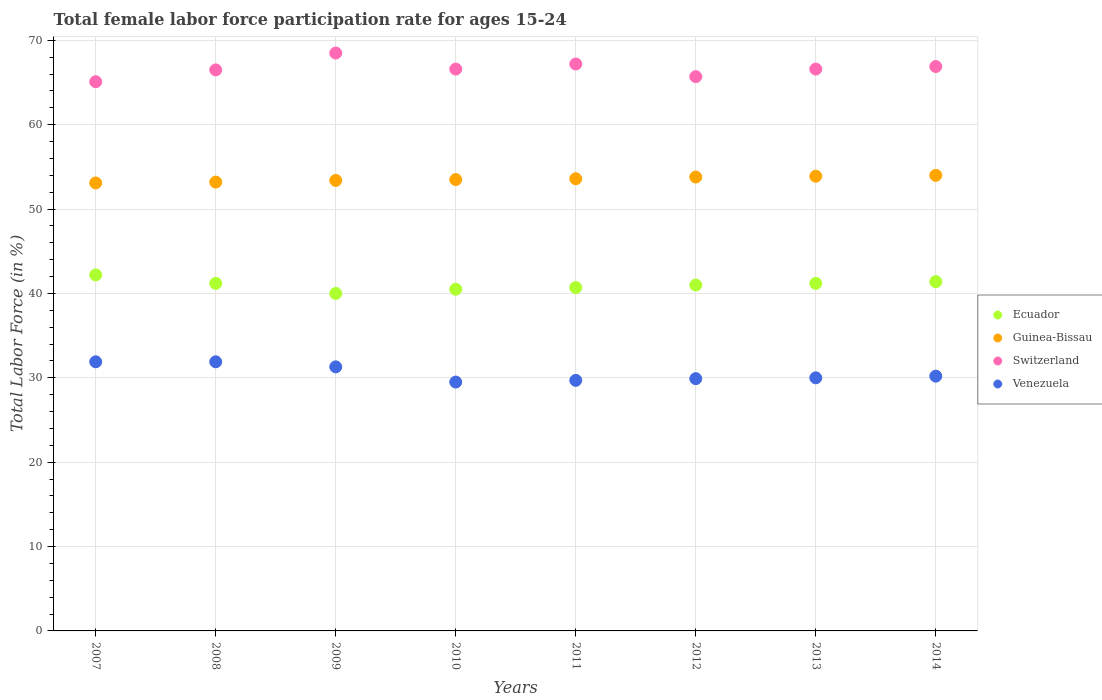Is the number of dotlines equal to the number of legend labels?
Your answer should be very brief. Yes. Across all years, what is the maximum female labor force participation rate in Guinea-Bissau?
Provide a succinct answer. 54. Across all years, what is the minimum female labor force participation rate in Ecuador?
Make the answer very short. 40. In which year was the female labor force participation rate in Ecuador maximum?
Make the answer very short. 2007. What is the total female labor force participation rate in Switzerland in the graph?
Keep it short and to the point. 533.1. What is the difference between the female labor force participation rate in Switzerland in 2010 and that in 2013?
Provide a succinct answer. 0. What is the difference between the female labor force participation rate in Switzerland in 2011 and the female labor force participation rate in Venezuela in 2012?
Give a very brief answer. 37.3. What is the average female labor force participation rate in Venezuela per year?
Offer a very short reply. 30.55. What is the ratio of the female labor force participation rate in Switzerland in 2008 to that in 2013?
Make the answer very short. 1. Is the female labor force participation rate in Venezuela in 2009 less than that in 2014?
Offer a very short reply. No. What is the difference between the highest and the lowest female labor force participation rate in Guinea-Bissau?
Ensure brevity in your answer.  0.9. In how many years, is the female labor force participation rate in Guinea-Bissau greater than the average female labor force participation rate in Guinea-Bissau taken over all years?
Your response must be concise. 4. Is the sum of the female labor force participation rate in Venezuela in 2012 and 2014 greater than the maximum female labor force participation rate in Ecuador across all years?
Provide a short and direct response. Yes. Is it the case that in every year, the sum of the female labor force participation rate in Switzerland and female labor force participation rate in Ecuador  is greater than the female labor force participation rate in Venezuela?
Offer a very short reply. Yes. Is the female labor force participation rate in Ecuador strictly greater than the female labor force participation rate in Venezuela over the years?
Provide a short and direct response. Yes. Is the female labor force participation rate in Switzerland strictly less than the female labor force participation rate in Guinea-Bissau over the years?
Your response must be concise. No. How many years are there in the graph?
Your answer should be compact. 8. Are the values on the major ticks of Y-axis written in scientific E-notation?
Offer a very short reply. No. Where does the legend appear in the graph?
Offer a terse response. Center right. How many legend labels are there?
Offer a very short reply. 4. What is the title of the graph?
Your answer should be compact. Total female labor force participation rate for ages 15-24. What is the label or title of the X-axis?
Offer a very short reply. Years. What is the Total Labor Force (in %) of Ecuador in 2007?
Provide a short and direct response. 42.2. What is the Total Labor Force (in %) in Guinea-Bissau in 2007?
Your answer should be very brief. 53.1. What is the Total Labor Force (in %) of Switzerland in 2007?
Offer a very short reply. 65.1. What is the Total Labor Force (in %) of Venezuela in 2007?
Make the answer very short. 31.9. What is the Total Labor Force (in %) in Ecuador in 2008?
Your response must be concise. 41.2. What is the Total Labor Force (in %) of Guinea-Bissau in 2008?
Make the answer very short. 53.2. What is the Total Labor Force (in %) in Switzerland in 2008?
Ensure brevity in your answer.  66.5. What is the Total Labor Force (in %) of Venezuela in 2008?
Make the answer very short. 31.9. What is the Total Labor Force (in %) in Guinea-Bissau in 2009?
Your response must be concise. 53.4. What is the Total Labor Force (in %) of Switzerland in 2009?
Provide a succinct answer. 68.5. What is the Total Labor Force (in %) of Venezuela in 2009?
Your answer should be compact. 31.3. What is the Total Labor Force (in %) in Ecuador in 2010?
Make the answer very short. 40.5. What is the Total Labor Force (in %) in Guinea-Bissau in 2010?
Provide a short and direct response. 53.5. What is the Total Labor Force (in %) of Switzerland in 2010?
Your answer should be very brief. 66.6. What is the Total Labor Force (in %) in Venezuela in 2010?
Provide a succinct answer. 29.5. What is the Total Labor Force (in %) of Ecuador in 2011?
Give a very brief answer. 40.7. What is the Total Labor Force (in %) of Guinea-Bissau in 2011?
Your answer should be very brief. 53.6. What is the Total Labor Force (in %) of Switzerland in 2011?
Your response must be concise. 67.2. What is the Total Labor Force (in %) in Venezuela in 2011?
Your response must be concise. 29.7. What is the Total Labor Force (in %) of Ecuador in 2012?
Your answer should be very brief. 41. What is the Total Labor Force (in %) of Guinea-Bissau in 2012?
Offer a very short reply. 53.8. What is the Total Labor Force (in %) of Switzerland in 2012?
Offer a terse response. 65.7. What is the Total Labor Force (in %) in Venezuela in 2012?
Ensure brevity in your answer.  29.9. What is the Total Labor Force (in %) of Ecuador in 2013?
Your response must be concise. 41.2. What is the Total Labor Force (in %) in Guinea-Bissau in 2013?
Give a very brief answer. 53.9. What is the Total Labor Force (in %) in Switzerland in 2013?
Your response must be concise. 66.6. What is the Total Labor Force (in %) in Venezuela in 2013?
Offer a terse response. 30. What is the Total Labor Force (in %) of Ecuador in 2014?
Provide a short and direct response. 41.4. What is the Total Labor Force (in %) of Switzerland in 2014?
Provide a short and direct response. 66.9. What is the Total Labor Force (in %) in Venezuela in 2014?
Provide a succinct answer. 30.2. Across all years, what is the maximum Total Labor Force (in %) of Ecuador?
Ensure brevity in your answer.  42.2. Across all years, what is the maximum Total Labor Force (in %) of Switzerland?
Ensure brevity in your answer.  68.5. Across all years, what is the maximum Total Labor Force (in %) in Venezuela?
Give a very brief answer. 31.9. Across all years, what is the minimum Total Labor Force (in %) in Ecuador?
Your answer should be very brief. 40. Across all years, what is the minimum Total Labor Force (in %) in Guinea-Bissau?
Your answer should be compact. 53.1. Across all years, what is the minimum Total Labor Force (in %) of Switzerland?
Offer a very short reply. 65.1. Across all years, what is the minimum Total Labor Force (in %) in Venezuela?
Your response must be concise. 29.5. What is the total Total Labor Force (in %) in Ecuador in the graph?
Give a very brief answer. 328.2. What is the total Total Labor Force (in %) in Guinea-Bissau in the graph?
Provide a short and direct response. 428.5. What is the total Total Labor Force (in %) of Switzerland in the graph?
Provide a short and direct response. 533.1. What is the total Total Labor Force (in %) of Venezuela in the graph?
Provide a succinct answer. 244.4. What is the difference between the Total Labor Force (in %) in Venezuela in 2007 and that in 2008?
Give a very brief answer. 0. What is the difference between the Total Labor Force (in %) in Ecuador in 2007 and that in 2009?
Provide a succinct answer. 2.2. What is the difference between the Total Labor Force (in %) of Switzerland in 2007 and that in 2009?
Keep it short and to the point. -3.4. What is the difference between the Total Labor Force (in %) of Venezuela in 2007 and that in 2009?
Make the answer very short. 0.6. What is the difference between the Total Labor Force (in %) of Ecuador in 2007 and that in 2010?
Ensure brevity in your answer.  1.7. What is the difference between the Total Labor Force (in %) of Guinea-Bissau in 2007 and that in 2010?
Provide a short and direct response. -0.4. What is the difference between the Total Labor Force (in %) in Switzerland in 2007 and that in 2011?
Provide a short and direct response. -2.1. What is the difference between the Total Labor Force (in %) of Venezuela in 2007 and that in 2011?
Your answer should be very brief. 2.2. What is the difference between the Total Labor Force (in %) in Guinea-Bissau in 2007 and that in 2012?
Make the answer very short. -0.7. What is the difference between the Total Labor Force (in %) in Ecuador in 2007 and that in 2013?
Your answer should be very brief. 1. What is the difference between the Total Labor Force (in %) of Guinea-Bissau in 2007 and that in 2013?
Your answer should be compact. -0.8. What is the difference between the Total Labor Force (in %) in Switzerland in 2007 and that in 2013?
Ensure brevity in your answer.  -1.5. What is the difference between the Total Labor Force (in %) in Venezuela in 2007 and that in 2013?
Give a very brief answer. 1.9. What is the difference between the Total Labor Force (in %) of Ecuador in 2007 and that in 2014?
Your response must be concise. 0.8. What is the difference between the Total Labor Force (in %) in Switzerland in 2007 and that in 2014?
Provide a short and direct response. -1.8. What is the difference between the Total Labor Force (in %) of Venezuela in 2007 and that in 2014?
Ensure brevity in your answer.  1.7. What is the difference between the Total Labor Force (in %) in Ecuador in 2008 and that in 2010?
Offer a terse response. 0.7. What is the difference between the Total Labor Force (in %) in Guinea-Bissau in 2008 and that in 2010?
Offer a terse response. -0.3. What is the difference between the Total Labor Force (in %) in Ecuador in 2008 and that in 2011?
Your answer should be very brief. 0.5. What is the difference between the Total Labor Force (in %) of Guinea-Bissau in 2008 and that in 2011?
Provide a short and direct response. -0.4. What is the difference between the Total Labor Force (in %) in Ecuador in 2008 and that in 2012?
Give a very brief answer. 0.2. What is the difference between the Total Labor Force (in %) of Switzerland in 2008 and that in 2012?
Provide a short and direct response. 0.8. What is the difference between the Total Labor Force (in %) of Guinea-Bissau in 2008 and that in 2013?
Offer a very short reply. -0.7. What is the difference between the Total Labor Force (in %) in Switzerland in 2008 and that in 2014?
Make the answer very short. -0.4. What is the difference between the Total Labor Force (in %) in Guinea-Bissau in 2009 and that in 2010?
Offer a terse response. -0.1. What is the difference between the Total Labor Force (in %) in Ecuador in 2009 and that in 2011?
Ensure brevity in your answer.  -0.7. What is the difference between the Total Labor Force (in %) in Guinea-Bissau in 2009 and that in 2011?
Give a very brief answer. -0.2. What is the difference between the Total Labor Force (in %) in Venezuela in 2009 and that in 2011?
Your response must be concise. 1.6. What is the difference between the Total Labor Force (in %) of Ecuador in 2009 and that in 2012?
Make the answer very short. -1. What is the difference between the Total Labor Force (in %) of Switzerland in 2009 and that in 2012?
Your answer should be compact. 2.8. What is the difference between the Total Labor Force (in %) of Venezuela in 2009 and that in 2012?
Your response must be concise. 1.4. What is the difference between the Total Labor Force (in %) in Switzerland in 2009 and that in 2013?
Give a very brief answer. 1.9. What is the difference between the Total Labor Force (in %) in Venezuela in 2009 and that in 2013?
Ensure brevity in your answer.  1.3. What is the difference between the Total Labor Force (in %) in Switzerland in 2009 and that in 2014?
Your answer should be very brief. 1.6. What is the difference between the Total Labor Force (in %) of Venezuela in 2009 and that in 2014?
Make the answer very short. 1.1. What is the difference between the Total Labor Force (in %) of Ecuador in 2010 and that in 2011?
Offer a very short reply. -0.2. What is the difference between the Total Labor Force (in %) in Guinea-Bissau in 2010 and that in 2011?
Ensure brevity in your answer.  -0.1. What is the difference between the Total Labor Force (in %) of Switzerland in 2010 and that in 2011?
Give a very brief answer. -0.6. What is the difference between the Total Labor Force (in %) in Switzerland in 2010 and that in 2012?
Your response must be concise. 0.9. What is the difference between the Total Labor Force (in %) of Ecuador in 2010 and that in 2013?
Give a very brief answer. -0.7. What is the difference between the Total Labor Force (in %) in Switzerland in 2010 and that in 2013?
Give a very brief answer. 0. What is the difference between the Total Labor Force (in %) in Guinea-Bissau in 2010 and that in 2014?
Keep it short and to the point. -0.5. What is the difference between the Total Labor Force (in %) of Ecuador in 2011 and that in 2012?
Your response must be concise. -0.3. What is the difference between the Total Labor Force (in %) of Guinea-Bissau in 2011 and that in 2012?
Ensure brevity in your answer.  -0.2. What is the difference between the Total Labor Force (in %) of Ecuador in 2011 and that in 2013?
Your answer should be very brief. -0.5. What is the difference between the Total Labor Force (in %) of Switzerland in 2011 and that in 2013?
Your answer should be compact. 0.6. What is the difference between the Total Labor Force (in %) of Venezuela in 2011 and that in 2013?
Provide a short and direct response. -0.3. What is the difference between the Total Labor Force (in %) of Ecuador in 2011 and that in 2014?
Ensure brevity in your answer.  -0.7. What is the difference between the Total Labor Force (in %) of Venezuela in 2011 and that in 2014?
Your response must be concise. -0.5. What is the difference between the Total Labor Force (in %) in Switzerland in 2012 and that in 2013?
Provide a succinct answer. -0.9. What is the difference between the Total Labor Force (in %) of Venezuela in 2012 and that in 2013?
Keep it short and to the point. -0.1. What is the difference between the Total Labor Force (in %) of Guinea-Bissau in 2012 and that in 2014?
Your answer should be compact. -0.2. What is the difference between the Total Labor Force (in %) in Ecuador in 2013 and that in 2014?
Ensure brevity in your answer.  -0.2. What is the difference between the Total Labor Force (in %) of Venezuela in 2013 and that in 2014?
Give a very brief answer. -0.2. What is the difference between the Total Labor Force (in %) in Ecuador in 2007 and the Total Labor Force (in %) in Switzerland in 2008?
Make the answer very short. -24.3. What is the difference between the Total Labor Force (in %) in Guinea-Bissau in 2007 and the Total Labor Force (in %) in Venezuela in 2008?
Your answer should be compact. 21.2. What is the difference between the Total Labor Force (in %) in Switzerland in 2007 and the Total Labor Force (in %) in Venezuela in 2008?
Your response must be concise. 33.2. What is the difference between the Total Labor Force (in %) of Ecuador in 2007 and the Total Labor Force (in %) of Guinea-Bissau in 2009?
Offer a very short reply. -11.2. What is the difference between the Total Labor Force (in %) in Ecuador in 2007 and the Total Labor Force (in %) in Switzerland in 2009?
Give a very brief answer. -26.3. What is the difference between the Total Labor Force (in %) of Ecuador in 2007 and the Total Labor Force (in %) of Venezuela in 2009?
Keep it short and to the point. 10.9. What is the difference between the Total Labor Force (in %) of Guinea-Bissau in 2007 and the Total Labor Force (in %) of Switzerland in 2009?
Your answer should be very brief. -15.4. What is the difference between the Total Labor Force (in %) in Guinea-Bissau in 2007 and the Total Labor Force (in %) in Venezuela in 2009?
Your response must be concise. 21.8. What is the difference between the Total Labor Force (in %) in Switzerland in 2007 and the Total Labor Force (in %) in Venezuela in 2009?
Make the answer very short. 33.8. What is the difference between the Total Labor Force (in %) in Ecuador in 2007 and the Total Labor Force (in %) in Switzerland in 2010?
Offer a very short reply. -24.4. What is the difference between the Total Labor Force (in %) of Guinea-Bissau in 2007 and the Total Labor Force (in %) of Venezuela in 2010?
Your answer should be compact. 23.6. What is the difference between the Total Labor Force (in %) of Switzerland in 2007 and the Total Labor Force (in %) of Venezuela in 2010?
Provide a succinct answer. 35.6. What is the difference between the Total Labor Force (in %) in Ecuador in 2007 and the Total Labor Force (in %) in Switzerland in 2011?
Ensure brevity in your answer.  -25. What is the difference between the Total Labor Force (in %) in Guinea-Bissau in 2007 and the Total Labor Force (in %) in Switzerland in 2011?
Your answer should be very brief. -14.1. What is the difference between the Total Labor Force (in %) of Guinea-Bissau in 2007 and the Total Labor Force (in %) of Venezuela in 2011?
Your response must be concise. 23.4. What is the difference between the Total Labor Force (in %) of Switzerland in 2007 and the Total Labor Force (in %) of Venezuela in 2011?
Your answer should be compact. 35.4. What is the difference between the Total Labor Force (in %) of Ecuador in 2007 and the Total Labor Force (in %) of Guinea-Bissau in 2012?
Ensure brevity in your answer.  -11.6. What is the difference between the Total Labor Force (in %) of Ecuador in 2007 and the Total Labor Force (in %) of Switzerland in 2012?
Provide a short and direct response. -23.5. What is the difference between the Total Labor Force (in %) of Ecuador in 2007 and the Total Labor Force (in %) of Venezuela in 2012?
Provide a short and direct response. 12.3. What is the difference between the Total Labor Force (in %) in Guinea-Bissau in 2007 and the Total Labor Force (in %) in Venezuela in 2012?
Make the answer very short. 23.2. What is the difference between the Total Labor Force (in %) of Switzerland in 2007 and the Total Labor Force (in %) of Venezuela in 2012?
Provide a succinct answer. 35.2. What is the difference between the Total Labor Force (in %) in Ecuador in 2007 and the Total Labor Force (in %) in Guinea-Bissau in 2013?
Provide a succinct answer. -11.7. What is the difference between the Total Labor Force (in %) of Ecuador in 2007 and the Total Labor Force (in %) of Switzerland in 2013?
Provide a succinct answer. -24.4. What is the difference between the Total Labor Force (in %) in Guinea-Bissau in 2007 and the Total Labor Force (in %) in Venezuela in 2013?
Your answer should be very brief. 23.1. What is the difference between the Total Labor Force (in %) of Switzerland in 2007 and the Total Labor Force (in %) of Venezuela in 2013?
Ensure brevity in your answer.  35.1. What is the difference between the Total Labor Force (in %) in Ecuador in 2007 and the Total Labor Force (in %) in Guinea-Bissau in 2014?
Offer a terse response. -11.8. What is the difference between the Total Labor Force (in %) of Ecuador in 2007 and the Total Labor Force (in %) of Switzerland in 2014?
Offer a terse response. -24.7. What is the difference between the Total Labor Force (in %) in Guinea-Bissau in 2007 and the Total Labor Force (in %) in Switzerland in 2014?
Ensure brevity in your answer.  -13.8. What is the difference between the Total Labor Force (in %) in Guinea-Bissau in 2007 and the Total Labor Force (in %) in Venezuela in 2014?
Make the answer very short. 22.9. What is the difference between the Total Labor Force (in %) in Switzerland in 2007 and the Total Labor Force (in %) in Venezuela in 2014?
Make the answer very short. 34.9. What is the difference between the Total Labor Force (in %) in Ecuador in 2008 and the Total Labor Force (in %) in Switzerland in 2009?
Give a very brief answer. -27.3. What is the difference between the Total Labor Force (in %) in Guinea-Bissau in 2008 and the Total Labor Force (in %) in Switzerland in 2009?
Offer a terse response. -15.3. What is the difference between the Total Labor Force (in %) in Guinea-Bissau in 2008 and the Total Labor Force (in %) in Venezuela in 2009?
Keep it short and to the point. 21.9. What is the difference between the Total Labor Force (in %) in Switzerland in 2008 and the Total Labor Force (in %) in Venezuela in 2009?
Keep it short and to the point. 35.2. What is the difference between the Total Labor Force (in %) of Ecuador in 2008 and the Total Labor Force (in %) of Guinea-Bissau in 2010?
Keep it short and to the point. -12.3. What is the difference between the Total Labor Force (in %) in Ecuador in 2008 and the Total Labor Force (in %) in Switzerland in 2010?
Provide a succinct answer. -25.4. What is the difference between the Total Labor Force (in %) of Ecuador in 2008 and the Total Labor Force (in %) of Venezuela in 2010?
Your answer should be compact. 11.7. What is the difference between the Total Labor Force (in %) in Guinea-Bissau in 2008 and the Total Labor Force (in %) in Venezuela in 2010?
Make the answer very short. 23.7. What is the difference between the Total Labor Force (in %) of Ecuador in 2008 and the Total Labor Force (in %) of Venezuela in 2011?
Make the answer very short. 11.5. What is the difference between the Total Labor Force (in %) of Guinea-Bissau in 2008 and the Total Labor Force (in %) of Switzerland in 2011?
Give a very brief answer. -14. What is the difference between the Total Labor Force (in %) in Switzerland in 2008 and the Total Labor Force (in %) in Venezuela in 2011?
Your response must be concise. 36.8. What is the difference between the Total Labor Force (in %) of Ecuador in 2008 and the Total Labor Force (in %) of Guinea-Bissau in 2012?
Offer a terse response. -12.6. What is the difference between the Total Labor Force (in %) in Ecuador in 2008 and the Total Labor Force (in %) in Switzerland in 2012?
Your answer should be compact. -24.5. What is the difference between the Total Labor Force (in %) in Guinea-Bissau in 2008 and the Total Labor Force (in %) in Venezuela in 2012?
Ensure brevity in your answer.  23.3. What is the difference between the Total Labor Force (in %) in Switzerland in 2008 and the Total Labor Force (in %) in Venezuela in 2012?
Your answer should be very brief. 36.6. What is the difference between the Total Labor Force (in %) of Ecuador in 2008 and the Total Labor Force (in %) of Switzerland in 2013?
Your answer should be compact. -25.4. What is the difference between the Total Labor Force (in %) of Guinea-Bissau in 2008 and the Total Labor Force (in %) of Switzerland in 2013?
Give a very brief answer. -13.4. What is the difference between the Total Labor Force (in %) in Guinea-Bissau in 2008 and the Total Labor Force (in %) in Venezuela in 2013?
Provide a short and direct response. 23.2. What is the difference between the Total Labor Force (in %) of Switzerland in 2008 and the Total Labor Force (in %) of Venezuela in 2013?
Give a very brief answer. 36.5. What is the difference between the Total Labor Force (in %) of Ecuador in 2008 and the Total Labor Force (in %) of Guinea-Bissau in 2014?
Make the answer very short. -12.8. What is the difference between the Total Labor Force (in %) in Ecuador in 2008 and the Total Labor Force (in %) in Switzerland in 2014?
Ensure brevity in your answer.  -25.7. What is the difference between the Total Labor Force (in %) in Ecuador in 2008 and the Total Labor Force (in %) in Venezuela in 2014?
Your answer should be very brief. 11. What is the difference between the Total Labor Force (in %) in Guinea-Bissau in 2008 and the Total Labor Force (in %) in Switzerland in 2014?
Offer a very short reply. -13.7. What is the difference between the Total Labor Force (in %) in Switzerland in 2008 and the Total Labor Force (in %) in Venezuela in 2014?
Offer a terse response. 36.3. What is the difference between the Total Labor Force (in %) in Ecuador in 2009 and the Total Labor Force (in %) in Switzerland in 2010?
Make the answer very short. -26.6. What is the difference between the Total Labor Force (in %) in Guinea-Bissau in 2009 and the Total Labor Force (in %) in Venezuela in 2010?
Your answer should be very brief. 23.9. What is the difference between the Total Labor Force (in %) of Ecuador in 2009 and the Total Labor Force (in %) of Switzerland in 2011?
Your response must be concise. -27.2. What is the difference between the Total Labor Force (in %) of Ecuador in 2009 and the Total Labor Force (in %) of Venezuela in 2011?
Provide a short and direct response. 10.3. What is the difference between the Total Labor Force (in %) of Guinea-Bissau in 2009 and the Total Labor Force (in %) of Switzerland in 2011?
Your answer should be compact. -13.8. What is the difference between the Total Labor Force (in %) in Guinea-Bissau in 2009 and the Total Labor Force (in %) in Venezuela in 2011?
Give a very brief answer. 23.7. What is the difference between the Total Labor Force (in %) of Switzerland in 2009 and the Total Labor Force (in %) of Venezuela in 2011?
Provide a short and direct response. 38.8. What is the difference between the Total Labor Force (in %) of Ecuador in 2009 and the Total Labor Force (in %) of Guinea-Bissau in 2012?
Give a very brief answer. -13.8. What is the difference between the Total Labor Force (in %) in Ecuador in 2009 and the Total Labor Force (in %) in Switzerland in 2012?
Keep it short and to the point. -25.7. What is the difference between the Total Labor Force (in %) in Ecuador in 2009 and the Total Labor Force (in %) in Venezuela in 2012?
Make the answer very short. 10.1. What is the difference between the Total Labor Force (in %) in Switzerland in 2009 and the Total Labor Force (in %) in Venezuela in 2012?
Offer a terse response. 38.6. What is the difference between the Total Labor Force (in %) of Ecuador in 2009 and the Total Labor Force (in %) of Switzerland in 2013?
Give a very brief answer. -26.6. What is the difference between the Total Labor Force (in %) in Ecuador in 2009 and the Total Labor Force (in %) in Venezuela in 2013?
Ensure brevity in your answer.  10. What is the difference between the Total Labor Force (in %) in Guinea-Bissau in 2009 and the Total Labor Force (in %) in Switzerland in 2013?
Offer a very short reply. -13.2. What is the difference between the Total Labor Force (in %) of Guinea-Bissau in 2009 and the Total Labor Force (in %) of Venezuela in 2013?
Provide a short and direct response. 23.4. What is the difference between the Total Labor Force (in %) of Switzerland in 2009 and the Total Labor Force (in %) of Venezuela in 2013?
Ensure brevity in your answer.  38.5. What is the difference between the Total Labor Force (in %) of Ecuador in 2009 and the Total Labor Force (in %) of Guinea-Bissau in 2014?
Ensure brevity in your answer.  -14. What is the difference between the Total Labor Force (in %) of Ecuador in 2009 and the Total Labor Force (in %) of Switzerland in 2014?
Make the answer very short. -26.9. What is the difference between the Total Labor Force (in %) of Ecuador in 2009 and the Total Labor Force (in %) of Venezuela in 2014?
Ensure brevity in your answer.  9.8. What is the difference between the Total Labor Force (in %) in Guinea-Bissau in 2009 and the Total Labor Force (in %) in Venezuela in 2014?
Your answer should be very brief. 23.2. What is the difference between the Total Labor Force (in %) in Switzerland in 2009 and the Total Labor Force (in %) in Venezuela in 2014?
Offer a very short reply. 38.3. What is the difference between the Total Labor Force (in %) of Ecuador in 2010 and the Total Labor Force (in %) of Switzerland in 2011?
Your answer should be very brief. -26.7. What is the difference between the Total Labor Force (in %) of Ecuador in 2010 and the Total Labor Force (in %) of Venezuela in 2011?
Give a very brief answer. 10.8. What is the difference between the Total Labor Force (in %) in Guinea-Bissau in 2010 and the Total Labor Force (in %) in Switzerland in 2011?
Offer a very short reply. -13.7. What is the difference between the Total Labor Force (in %) of Guinea-Bissau in 2010 and the Total Labor Force (in %) of Venezuela in 2011?
Give a very brief answer. 23.8. What is the difference between the Total Labor Force (in %) of Switzerland in 2010 and the Total Labor Force (in %) of Venezuela in 2011?
Keep it short and to the point. 36.9. What is the difference between the Total Labor Force (in %) of Ecuador in 2010 and the Total Labor Force (in %) of Switzerland in 2012?
Give a very brief answer. -25.2. What is the difference between the Total Labor Force (in %) of Guinea-Bissau in 2010 and the Total Labor Force (in %) of Venezuela in 2012?
Offer a terse response. 23.6. What is the difference between the Total Labor Force (in %) in Switzerland in 2010 and the Total Labor Force (in %) in Venezuela in 2012?
Your response must be concise. 36.7. What is the difference between the Total Labor Force (in %) of Ecuador in 2010 and the Total Labor Force (in %) of Guinea-Bissau in 2013?
Offer a very short reply. -13.4. What is the difference between the Total Labor Force (in %) of Ecuador in 2010 and the Total Labor Force (in %) of Switzerland in 2013?
Keep it short and to the point. -26.1. What is the difference between the Total Labor Force (in %) in Switzerland in 2010 and the Total Labor Force (in %) in Venezuela in 2013?
Keep it short and to the point. 36.6. What is the difference between the Total Labor Force (in %) of Ecuador in 2010 and the Total Labor Force (in %) of Guinea-Bissau in 2014?
Make the answer very short. -13.5. What is the difference between the Total Labor Force (in %) in Ecuador in 2010 and the Total Labor Force (in %) in Switzerland in 2014?
Offer a very short reply. -26.4. What is the difference between the Total Labor Force (in %) in Ecuador in 2010 and the Total Labor Force (in %) in Venezuela in 2014?
Provide a succinct answer. 10.3. What is the difference between the Total Labor Force (in %) in Guinea-Bissau in 2010 and the Total Labor Force (in %) in Switzerland in 2014?
Ensure brevity in your answer.  -13.4. What is the difference between the Total Labor Force (in %) in Guinea-Bissau in 2010 and the Total Labor Force (in %) in Venezuela in 2014?
Provide a succinct answer. 23.3. What is the difference between the Total Labor Force (in %) of Switzerland in 2010 and the Total Labor Force (in %) of Venezuela in 2014?
Your answer should be very brief. 36.4. What is the difference between the Total Labor Force (in %) in Ecuador in 2011 and the Total Labor Force (in %) in Guinea-Bissau in 2012?
Your answer should be very brief. -13.1. What is the difference between the Total Labor Force (in %) in Ecuador in 2011 and the Total Labor Force (in %) in Venezuela in 2012?
Provide a short and direct response. 10.8. What is the difference between the Total Labor Force (in %) of Guinea-Bissau in 2011 and the Total Labor Force (in %) of Switzerland in 2012?
Provide a succinct answer. -12.1. What is the difference between the Total Labor Force (in %) in Guinea-Bissau in 2011 and the Total Labor Force (in %) in Venezuela in 2012?
Offer a terse response. 23.7. What is the difference between the Total Labor Force (in %) of Switzerland in 2011 and the Total Labor Force (in %) of Venezuela in 2012?
Offer a very short reply. 37.3. What is the difference between the Total Labor Force (in %) of Ecuador in 2011 and the Total Labor Force (in %) of Switzerland in 2013?
Keep it short and to the point. -25.9. What is the difference between the Total Labor Force (in %) in Ecuador in 2011 and the Total Labor Force (in %) in Venezuela in 2013?
Provide a succinct answer. 10.7. What is the difference between the Total Labor Force (in %) in Guinea-Bissau in 2011 and the Total Labor Force (in %) in Switzerland in 2013?
Offer a terse response. -13. What is the difference between the Total Labor Force (in %) of Guinea-Bissau in 2011 and the Total Labor Force (in %) of Venezuela in 2013?
Your answer should be compact. 23.6. What is the difference between the Total Labor Force (in %) in Switzerland in 2011 and the Total Labor Force (in %) in Venezuela in 2013?
Offer a very short reply. 37.2. What is the difference between the Total Labor Force (in %) of Ecuador in 2011 and the Total Labor Force (in %) of Switzerland in 2014?
Your answer should be very brief. -26.2. What is the difference between the Total Labor Force (in %) in Guinea-Bissau in 2011 and the Total Labor Force (in %) in Venezuela in 2014?
Provide a short and direct response. 23.4. What is the difference between the Total Labor Force (in %) in Ecuador in 2012 and the Total Labor Force (in %) in Guinea-Bissau in 2013?
Offer a terse response. -12.9. What is the difference between the Total Labor Force (in %) of Ecuador in 2012 and the Total Labor Force (in %) of Switzerland in 2013?
Your answer should be very brief. -25.6. What is the difference between the Total Labor Force (in %) of Ecuador in 2012 and the Total Labor Force (in %) of Venezuela in 2013?
Make the answer very short. 11. What is the difference between the Total Labor Force (in %) in Guinea-Bissau in 2012 and the Total Labor Force (in %) in Switzerland in 2013?
Ensure brevity in your answer.  -12.8. What is the difference between the Total Labor Force (in %) in Guinea-Bissau in 2012 and the Total Labor Force (in %) in Venezuela in 2013?
Your response must be concise. 23.8. What is the difference between the Total Labor Force (in %) in Switzerland in 2012 and the Total Labor Force (in %) in Venezuela in 2013?
Offer a very short reply. 35.7. What is the difference between the Total Labor Force (in %) in Ecuador in 2012 and the Total Labor Force (in %) in Guinea-Bissau in 2014?
Offer a very short reply. -13. What is the difference between the Total Labor Force (in %) in Ecuador in 2012 and the Total Labor Force (in %) in Switzerland in 2014?
Your answer should be compact. -25.9. What is the difference between the Total Labor Force (in %) in Ecuador in 2012 and the Total Labor Force (in %) in Venezuela in 2014?
Your response must be concise. 10.8. What is the difference between the Total Labor Force (in %) of Guinea-Bissau in 2012 and the Total Labor Force (in %) of Switzerland in 2014?
Make the answer very short. -13.1. What is the difference between the Total Labor Force (in %) in Guinea-Bissau in 2012 and the Total Labor Force (in %) in Venezuela in 2014?
Make the answer very short. 23.6. What is the difference between the Total Labor Force (in %) of Switzerland in 2012 and the Total Labor Force (in %) of Venezuela in 2014?
Make the answer very short. 35.5. What is the difference between the Total Labor Force (in %) in Ecuador in 2013 and the Total Labor Force (in %) in Guinea-Bissau in 2014?
Provide a succinct answer. -12.8. What is the difference between the Total Labor Force (in %) of Ecuador in 2013 and the Total Labor Force (in %) of Switzerland in 2014?
Your response must be concise. -25.7. What is the difference between the Total Labor Force (in %) of Guinea-Bissau in 2013 and the Total Labor Force (in %) of Switzerland in 2014?
Offer a terse response. -13. What is the difference between the Total Labor Force (in %) in Guinea-Bissau in 2013 and the Total Labor Force (in %) in Venezuela in 2014?
Make the answer very short. 23.7. What is the difference between the Total Labor Force (in %) in Switzerland in 2013 and the Total Labor Force (in %) in Venezuela in 2014?
Provide a succinct answer. 36.4. What is the average Total Labor Force (in %) in Ecuador per year?
Ensure brevity in your answer.  41.02. What is the average Total Labor Force (in %) in Guinea-Bissau per year?
Provide a short and direct response. 53.56. What is the average Total Labor Force (in %) in Switzerland per year?
Make the answer very short. 66.64. What is the average Total Labor Force (in %) in Venezuela per year?
Your response must be concise. 30.55. In the year 2007, what is the difference between the Total Labor Force (in %) in Ecuador and Total Labor Force (in %) in Switzerland?
Provide a short and direct response. -22.9. In the year 2007, what is the difference between the Total Labor Force (in %) in Ecuador and Total Labor Force (in %) in Venezuela?
Your answer should be very brief. 10.3. In the year 2007, what is the difference between the Total Labor Force (in %) of Guinea-Bissau and Total Labor Force (in %) of Switzerland?
Provide a short and direct response. -12. In the year 2007, what is the difference between the Total Labor Force (in %) in Guinea-Bissau and Total Labor Force (in %) in Venezuela?
Offer a very short reply. 21.2. In the year 2007, what is the difference between the Total Labor Force (in %) in Switzerland and Total Labor Force (in %) in Venezuela?
Give a very brief answer. 33.2. In the year 2008, what is the difference between the Total Labor Force (in %) of Ecuador and Total Labor Force (in %) of Guinea-Bissau?
Your answer should be very brief. -12. In the year 2008, what is the difference between the Total Labor Force (in %) in Ecuador and Total Labor Force (in %) in Switzerland?
Ensure brevity in your answer.  -25.3. In the year 2008, what is the difference between the Total Labor Force (in %) of Guinea-Bissau and Total Labor Force (in %) of Switzerland?
Keep it short and to the point. -13.3. In the year 2008, what is the difference between the Total Labor Force (in %) in Guinea-Bissau and Total Labor Force (in %) in Venezuela?
Give a very brief answer. 21.3. In the year 2008, what is the difference between the Total Labor Force (in %) in Switzerland and Total Labor Force (in %) in Venezuela?
Offer a terse response. 34.6. In the year 2009, what is the difference between the Total Labor Force (in %) in Ecuador and Total Labor Force (in %) in Guinea-Bissau?
Your answer should be very brief. -13.4. In the year 2009, what is the difference between the Total Labor Force (in %) of Ecuador and Total Labor Force (in %) of Switzerland?
Keep it short and to the point. -28.5. In the year 2009, what is the difference between the Total Labor Force (in %) in Ecuador and Total Labor Force (in %) in Venezuela?
Offer a terse response. 8.7. In the year 2009, what is the difference between the Total Labor Force (in %) of Guinea-Bissau and Total Labor Force (in %) of Switzerland?
Keep it short and to the point. -15.1. In the year 2009, what is the difference between the Total Labor Force (in %) of Guinea-Bissau and Total Labor Force (in %) of Venezuela?
Keep it short and to the point. 22.1. In the year 2009, what is the difference between the Total Labor Force (in %) in Switzerland and Total Labor Force (in %) in Venezuela?
Your answer should be very brief. 37.2. In the year 2010, what is the difference between the Total Labor Force (in %) in Ecuador and Total Labor Force (in %) in Switzerland?
Offer a very short reply. -26.1. In the year 2010, what is the difference between the Total Labor Force (in %) in Ecuador and Total Labor Force (in %) in Venezuela?
Ensure brevity in your answer.  11. In the year 2010, what is the difference between the Total Labor Force (in %) in Guinea-Bissau and Total Labor Force (in %) in Venezuela?
Keep it short and to the point. 24. In the year 2010, what is the difference between the Total Labor Force (in %) in Switzerland and Total Labor Force (in %) in Venezuela?
Your answer should be very brief. 37.1. In the year 2011, what is the difference between the Total Labor Force (in %) of Ecuador and Total Labor Force (in %) of Switzerland?
Provide a succinct answer. -26.5. In the year 2011, what is the difference between the Total Labor Force (in %) of Guinea-Bissau and Total Labor Force (in %) of Venezuela?
Give a very brief answer. 23.9. In the year 2011, what is the difference between the Total Labor Force (in %) in Switzerland and Total Labor Force (in %) in Venezuela?
Ensure brevity in your answer.  37.5. In the year 2012, what is the difference between the Total Labor Force (in %) in Ecuador and Total Labor Force (in %) in Switzerland?
Provide a succinct answer. -24.7. In the year 2012, what is the difference between the Total Labor Force (in %) in Ecuador and Total Labor Force (in %) in Venezuela?
Make the answer very short. 11.1. In the year 2012, what is the difference between the Total Labor Force (in %) of Guinea-Bissau and Total Labor Force (in %) of Switzerland?
Your answer should be compact. -11.9. In the year 2012, what is the difference between the Total Labor Force (in %) of Guinea-Bissau and Total Labor Force (in %) of Venezuela?
Your answer should be compact. 23.9. In the year 2012, what is the difference between the Total Labor Force (in %) in Switzerland and Total Labor Force (in %) in Venezuela?
Make the answer very short. 35.8. In the year 2013, what is the difference between the Total Labor Force (in %) in Ecuador and Total Labor Force (in %) in Switzerland?
Offer a very short reply. -25.4. In the year 2013, what is the difference between the Total Labor Force (in %) of Ecuador and Total Labor Force (in %) of Venezuela?
Your response must be concise. 11.2. In the year 2013, what is the difference between the Total Labor Force (in %) of Guinea-Bissau and Total Labor Force (in %) of Venezuela?
Make the answer very short. 23.9. In the year 2013, what is the difference between the Total Labor Force (in %) of Switzerland and Total Labor Force (in %) of Venezuela?
Offer a very short reply. 36.6. In the year 2014, what is the difference between the Total Labor Force (in %) in Ecuador and Total Labor Force (in %) in Guinea-Bissau?
Ensure brevity in your answer.  -12.6. In the year 2014, what is the difference between the Total Labor Force (in %) in Ecuador and Total Labor Force (in %) in Switzerland?
Your answer should be compact. -25.5. In the year 2014, what is the difference between the Total Labor Force (in %) of Guinea-Bissau and Total Labor Force (in %) of Venezuela?
Your answer should be very brief. 23.8. In the year 2014, what is the difference between the Total Labor Force (in %) of Switzerland and Total Labor Force (in %) of Venezuela?
Keep it short and to the point. 36.7. What is the ratio of the Total Labor Force (in %) of Ecuador in 2007 to that in 2008?
Your answer should be very brief. 1.02. What is the ratio of the Total Labor Force (in %) in Guinea-Bissau in 2007 to that in 2008?
Offer a terse response. 1. What is the ratio of the Total Labor Force (in %) of Switzerland in 2007 to that in 2008?
Your answer should be very brief. 0.98. What is the ratio of the Total Labor Force (in %) in Venezuela in 2007 to that in 2008?
Provide a short and direct response. 1. What is the ratio of the Total Labor Force (in %) in Ecuador in 2007 to that in 2009?
Keep it short and to the point. 1.05. What is the ratio of the Total Labor Force (in %) of Guinea-Bissau in 2007 to that in 2009?
Make the answer very short. 0.99. What is the ratio of the Total Labor Force (in %) of Switzerland in 2007 to that in 2009?
Offer a very short reply. 0.95. What is the ratio of the Total Labor Force (in %) of Venezuela in 2007 to that in 2009?
Offer a very short reply. 1.02. What is the ratio of the Total Labor Force (in %) of Ecuador in 2007 to that in 2010?
Your answer should be very brief. 1.04. What is the ratio of the Total Labor Force (in %) of Switzerland in 2007 to that in 2010?
Provide a succinct answer. 0.98. What is the ratio of the Total Labor Force (in %) in Venezuela in 2007 to that in 2010?
Offer a terse response. 1.08. What is the ratio of the Total Labor Force (in %) of Ecuador in 2007 to that in 2011?
Your answer should be very brief. 1.04. What is the ratio of the Total Labor Force (in %) in Switzerland in 2007 to that in 2011?
Your answer should be very brief. 0.97. What is the ratio of the Total Labor Force (in %) in Venezuela in 2007 to that in 2011?
Ensure brevity in your answer.  1.07. What is the ratio of the Total Labor Force (in %) in Ecuador in 2007 to that in 2012?
Offer a terse response. 1.03. What is the ratio of the Total Labor Force (in %) of Guinea-Bissau in 2007 to that in 2012?
Your answer should be very brief. 0.99. What is the ratio of the Total Labor Force (in %) of Switzerland in 2007 to that in 2012?
Give a very brief answer. 0.99. What is the ratio of the Total Labor Force (in %) of Venezuela in 2007 to that in 2012?
Your answer should be very brief. 1.07. What is the ratio of the Total Labor Force (in %) in Ecuador in 2007 to that in 2013?
Provide a succinct answer. 1.02. What is the ratio of the Total Labor Force (in %) in Guinea-Bissau in 2007 to that in 2013?
Make the answer very short. 0.99. What is the ratio of the Total Labor Force (in %) of Switzerland in 2007 to that in 2013?
Offer a terse response. 0.98. What is the ratio of the Total Labor Force (in %) in Venezuela in 2007 to that in 2013?
Ensure brevity in your answer.  1.06. What is the ratio of the Total Labor Force (in %) in Ecuador in 2007 to that in 2014?
Offer a very short reply. 1.02. What is the ratio of the Total Labor Force (in %) of Guinea-Bissau in 2007 to that in 2014?
Offer a terse response. 0.98. What is the ratio of the Total Labor Force (in %) of Switzerland in 2007 to that in 2014?
Your answer should be very brief. 0.97. What is the ratio of the Total Labor Force (in %) of Venezuela in 2007 to that in 2014?
Your answer should be compact. 1.06. What is the ratio of the Total Labor Force (in %) in Guinea-Bissau in 2008 to that in 2009?
Give a very brief answer. 1. What is the ratio of the Total Labor Force (in %) in Switzerland in 2008 to that in 2009?
Provide a succinct answer. 0.97. What is the ratio of the Total Labor Force (in %) of Venezuela in 2008 to that in 2009?
Provide a short and direct response. 1.02. What is the ratio of the Total Labor Force (in %) of Ecuador in 2008 to that in 2010?
Offer a terse response. 1.02. What is the ratio of the Total Labor Force (in %) in Switzerland in 2008 to that in 2010?
Your answer should be very brief. 1. What is the ratio of the Total Labor Force (in %) of Venezuela in 2008 to that in 2010?
Your answer should be compact. 1.08. What is the ratio of the Total Labor Force (in %) of Ecuador in 2008 to that in 2011?
Make the answer very short. 1.01. What is the ratio of the Total Labor Force (in %) of Guinea-Bissau in 2008 to that in 2011?
Provide a succinct answer. 0.99. What is the ratio of the Total Labor Force (in %) of Venezuela in 2008 to that in 2011?
Your answer should be compact. 1.07. What is the ratio of the Total Labor Force (in %) in Switzerland in 2008 to that in 2012?
Your answer should be very brief. 1.01. What is the ratio of the Total Labor Force (in %) of Venezuela in 2008 to that in 2012?
Make the answer very short. 1.07. What is the ratio of the Total Labor Force (in %) of Guinea-Bissau in 2008 to that in 2013?
Your response must be concise. 0.99. What is the ratio of the Total Labor Force (in %) in Venezuela in 2008 to that in 2013?
Your answer should be compact. 1.06. What is the ratio of the Total Labor Force (in %) in Ecuador in 2008 to that in 2014?
Your answer should be very brief. 1. What is the ratio of the Total Labor Force (in %) in Guinea-Bissau in 2008 to that in 2014?
Provide a succinct answer. 0.99. What is the ratio of the Total Labor Force (in %) in Venezuela in 2008 to that in 2014?
Ensure brevity in your answer.  1.06. What is the ratio of the Total Labor Force (in %) of Guinea-Bissau in 2009 to that in 2010?
Offer a very short reply. 1. What is the ratio of the Total Labor Force (in %) in Switzerland in 2009 to that in 2010?
Provide a short and direct response. 1.03. What is the ratio of the Total Labor Force (in %) of Venezuela in 2009 to that in 2010?
Your answer should be compact. 1.06. What is the ratio of the Total Labor Force (in %) of Ecuador in 2009 to that in 2011?
Provide a succinct answer. 0.98. What is the ratio of the Total Labor Force (in %) of Switzerland in 2009 to that in 2011?
Offer a terse response. 1.02. What is the ratio of the Total Labor Force (in %) in Venezuela in 2009 to that in 2011?
Provide a short and direct response. 1.05. What is the ratio of the Total Labor Force (in %) of Ecuador in 2009 to that in 2012?
Your response must be concise. 0.98. What is the ratio of the Total Labor Force (in %) in Switzerland in 2009 to that in 2012?
Offer a terse response. 1.04. What is the ratio of the Total Labor Force (in %) in Venezuela in 2009 to that in 2012?
Provide a short and direct response. 1.05. What is the ratio of the Total Labor Force (in %) of Ecuador in 2009 to that in 2013?
Provide a succinct answer. 0.97. What is the ratio of the Total Labor Force (in %) in Switzerland in 2009 to that in 2013?
Offer a very short reply. 1.03. What is the ratio of the Total Labor Force (in %) in Venezuela in 2009 to that in 2013?
Provide a succinct answer. 1.04. What is the ratio of the Total Labor Force (in %) in Ecuador in 2009 to that in 2014?
Your answer should be very brief. 0.97. What is the ratio of the Total Labor Force (in %) in Guinea-Bissau in 2009 to that in 2014?
Offer a very short reply. 0.99. What is the ratio of the Total Labor Force (in %) in Switzerland in 2009 to that in 2014?
Your answer should be very brief. 1.02. What is the ratio of the Total Labor Force (in %) in Venezuela in 2009 to that in 2014?
Offer a very short reply. 1.04. What is the ratio of the Total Labor Force (in %) of Ecuador in 2010 to that in 2011?
Your response must be concise. 1. What is the ratio of the Total Labor Force (in %) in Switzerland in 2010 to that in 2011?
Offer a very short reply. 0.99. What is the ratio of the Total Labor Force (in %) of Switzerland in 2010 to that in 2012?
Offer a terse response. 1.01. What is the ratio of the Total Labor Force (in %) of Venezuela in 2010 to that in 2012?
Provide a succinct answer. 0.99. What is the ratio of the Total Labor Force (in %) of Ecuador in 2010 to that in 2013?
Provide a short and direct response. 0.98. What is the ratio of the Total Labor Force (in %) of Guinea-Bissau in 2010 to that in 2013?
Offer a terse response. 0.99. What is the ratio of the Total Labor Force (in %) in Venezuela in 2010 to that in 2013?
Provide a succinct answer. 0.98. What is the ratio of the Total Labor Force (in %) of Ecuador in 2010 to that in 2014?
Make the answer very short. 0.98. What is the ratio of the Total Labor Force (in %) of Switzerland in 2010 to that in 2014?
Give a very brief answer. 1. What is the ratio of the Total Labor Force (in %) of Venezuela in 2010 to that in 2014?
Provide a short and direct response. 0.98. What is the ratio of the Total Labor Force (in %) in Guinea-Bissau in 2011 to that in 2012?
Offer a terse response. 1. What is the ratio of the Total Labor Force (in %) of Switzerland in 2011 to that in 2012?
Your answer should be very brief. 1.02. What is the ratio of the Total Labor Force (in %) of Venezuela in 2011 to that in 2012?
Keep it short and to the point. 0.99. What is the ratio of the Total Labor Force (in %) of Ecuador in 2011 to that in 2013?
Ensure brevity in your answer.  0.99. What is the ratio of the Total Labor Force (in %) in Guinea-Bissau in 2011 to that in 2013?
Your answer should be very brief. 0.99. What is the ratio of the Total Labor Force (in %) of Switzerland in 2011 to that in 2013?
Offer a very short reply. 1.01. What is the ratio of the Total Labor Force (in %) of Venezuela in 2011 to that in 2013?
Offer a terse response. 0.99. What is the ratio of the Total Labor Force (in %) in Ecuador in 2011 to that in 2014?
Provide a short and direct response. 0.98. What is the ratio of the Total Labor Force (in %) in Venezuela in 2011 to that in 2014?
Offer a terse response. 0.98. What is the ratio of the Total Labor Force (in %) of Switzerland in 2012 to that in 2013?
Offer a terse response. 0.99. What is the ratio of the Total Labor Force (in %) of Ecuador in 2012 to that in 2014?
Ensure brevity in your answer.  0.99. What is the ratio of the Total Labor Force (in %) in Switzerland in 2012 to that in 2014?
Your answer should be compact. 0.98. What is the ratio of the Total Labor Force (in %) of Switzerland in 2013 to that in 2014?
Your response must be concise. 1. What is the ratio of the Total Labor Force (in %) in Venezuela in 2013 to that in 2014?
Keep it short and to the point. 0.99. What is the difference between the highest and the second highest Total Labor Force (in %) of Guinea-Bissau?
Offer a very short reply. 0.1. What is the difference between the highest and the lowest Total Labor Force (in %) in Ecuador?
Keep it short and to the point. 2.2. What is the difference between the highest and the lowest Total Labor Force (in %) in Guinea-Bissau?
Provide a succinct answer. 0.9. What is the difference between the highest and the lowest Total Labor Force (in %) in Switzerland?
Give a very brief answer. 3.4. What is the difference between the highest and the lowest Total Labor Force (in %) of Venezuela?
Ensure brevity in your answer.  2.4. 